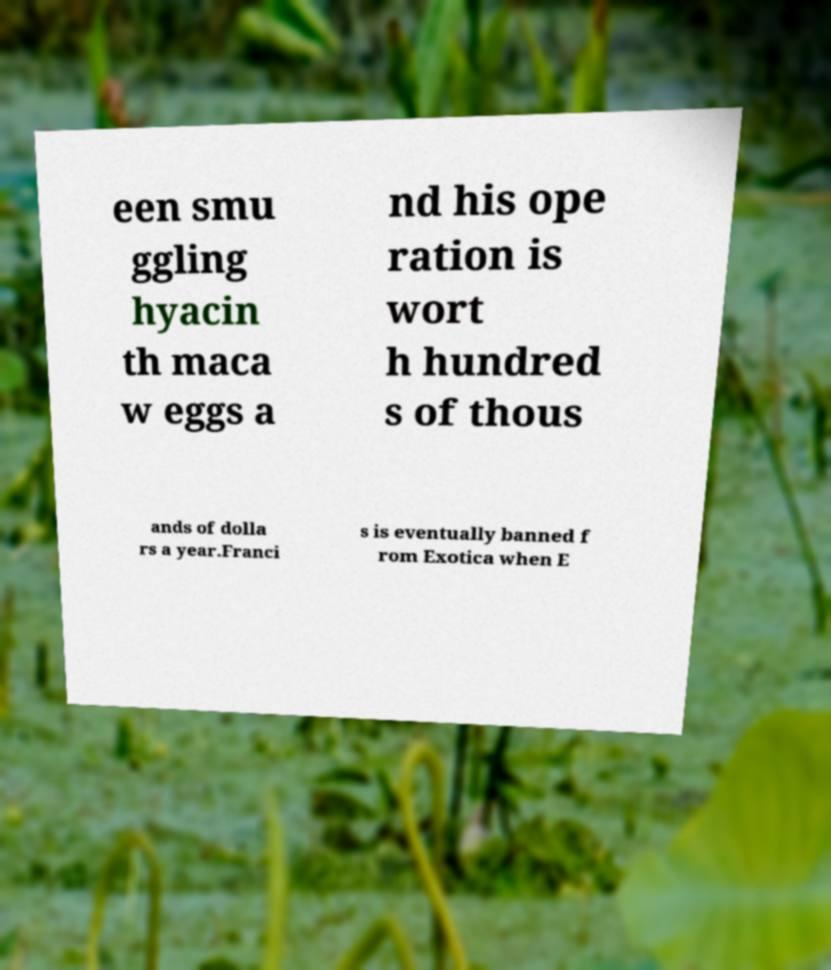Can you read and provide the text displayed in the image?This photo seems to have some interesting text. Can you extract and type it out for me? een smu ggling hyacin th maca w eggs a nd his ope ration is wort h hundred s of thous ands of dolla rs a year.Franci s is eventually banned f rom Exotica when E 